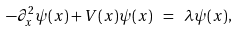Convert formula to latex. <formula><loc_0><loc_0><loc_500><loc_500>- \partial _ { x } ^ { 2 } \psi ( x ) + V ( x ) \psi ( x ) \ = \ \lambda \psi ( x ) ,</formula> 